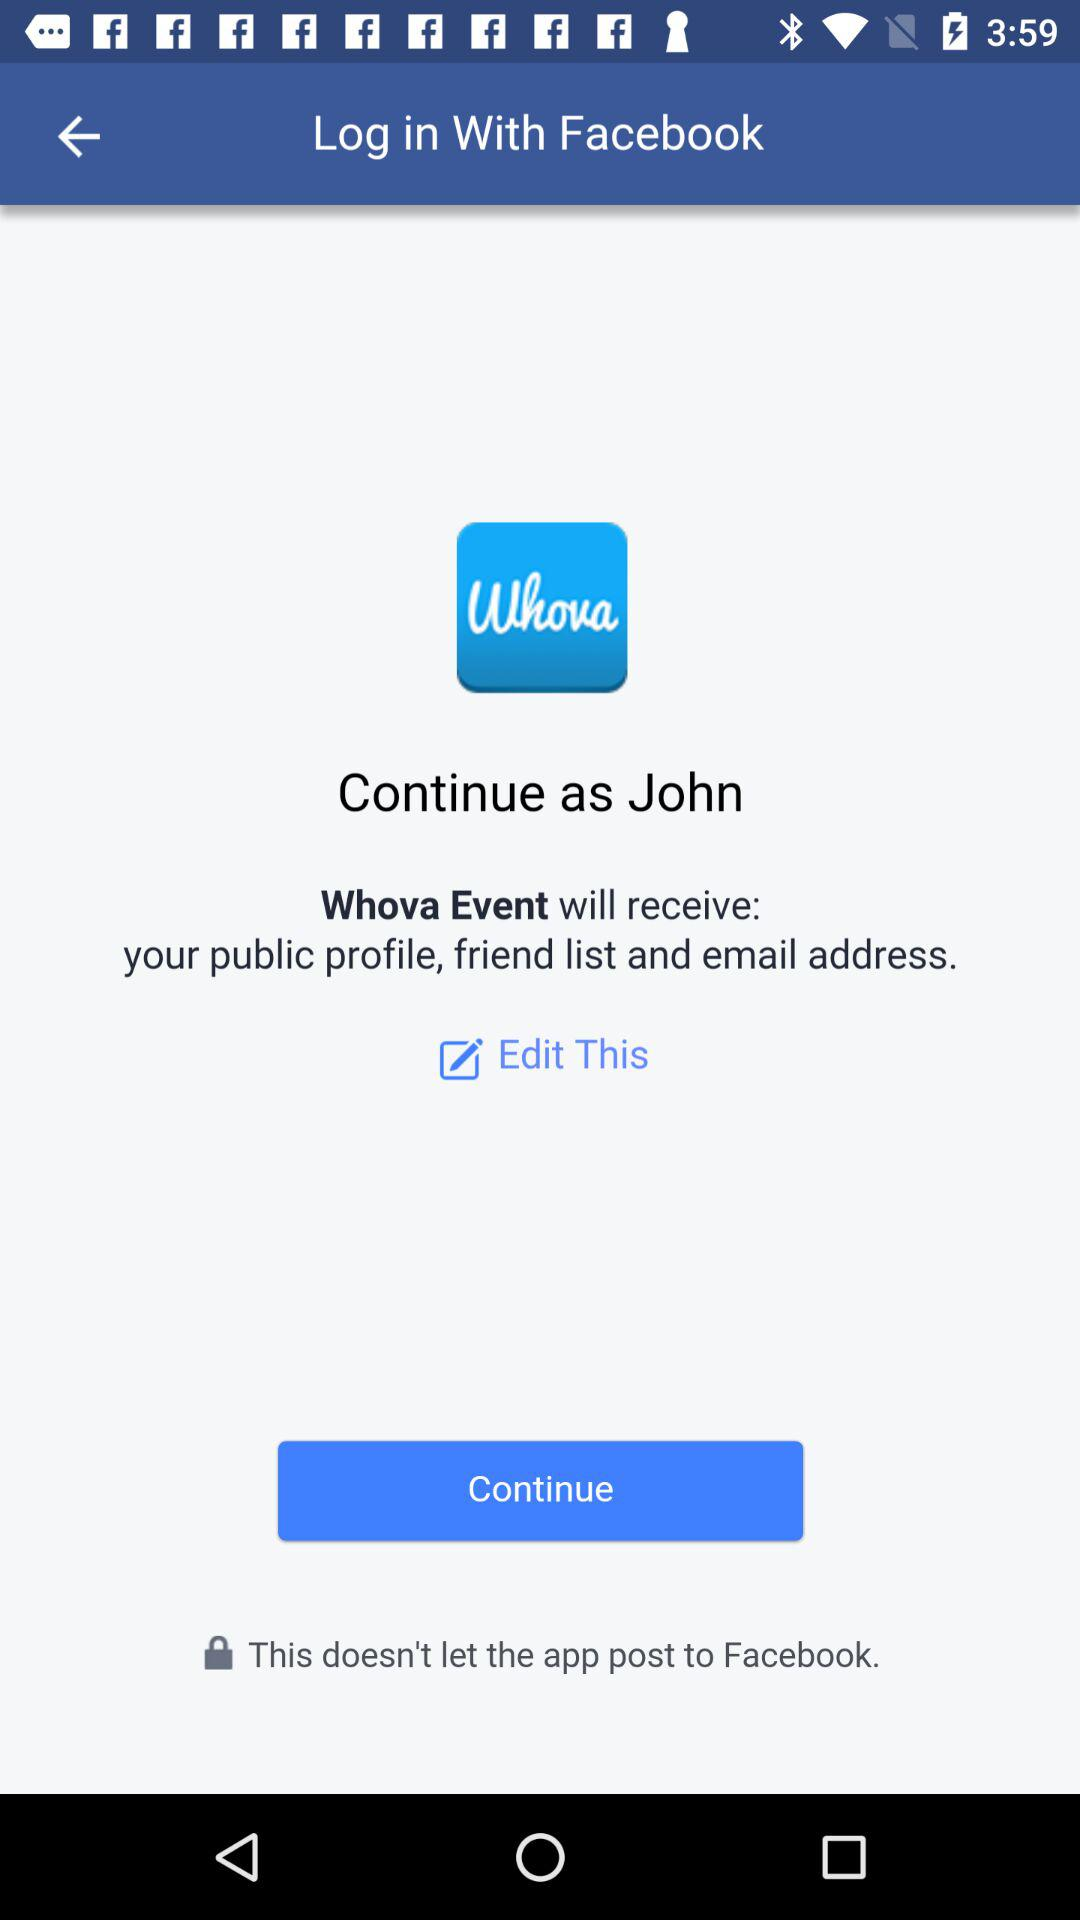What application is asking for permission? The application that is asking for permission is "Whova Event". 